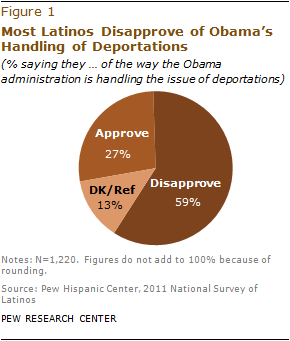Outline some significant characteristics in this image. The percentage difference between approve and disapprove is 32. 